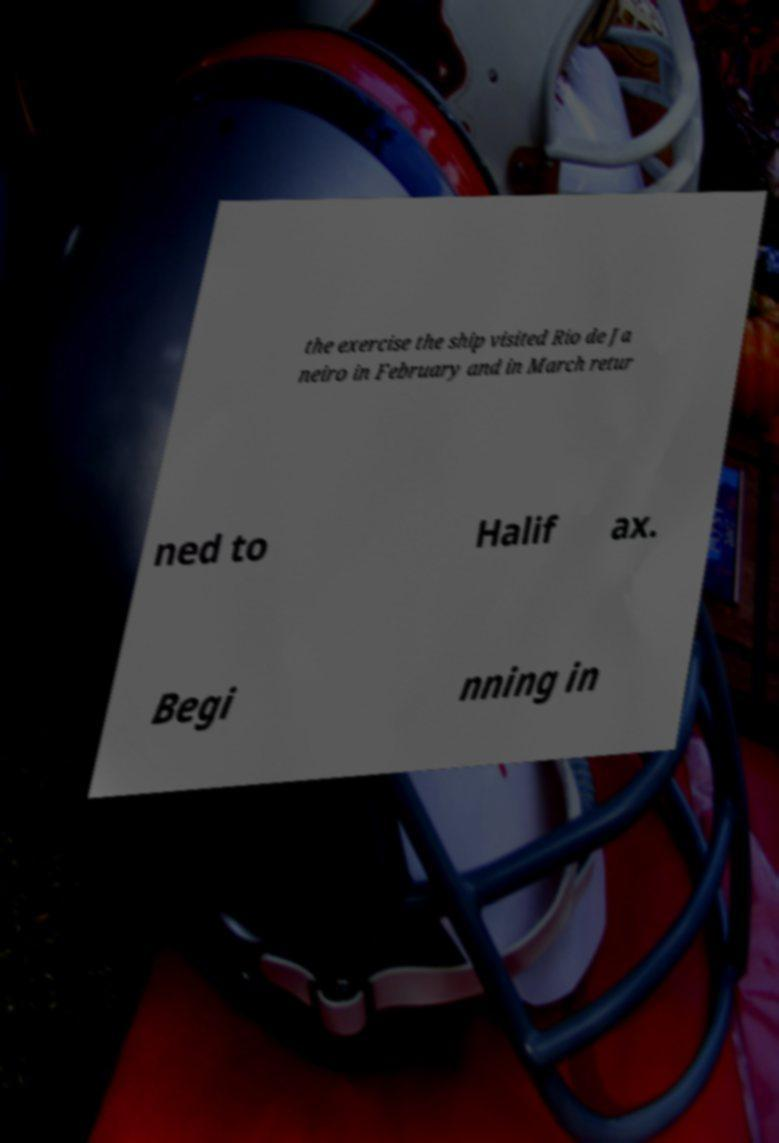Could you extract and type out the text from this image? the exercise the ship visited Rio de Ja neiro in February and in March retur ned to Halif ax. Begi nning in 